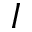Convert formula to latex. <formula><loc_0><loc_0><loc_500><loc_500>I</formula> 